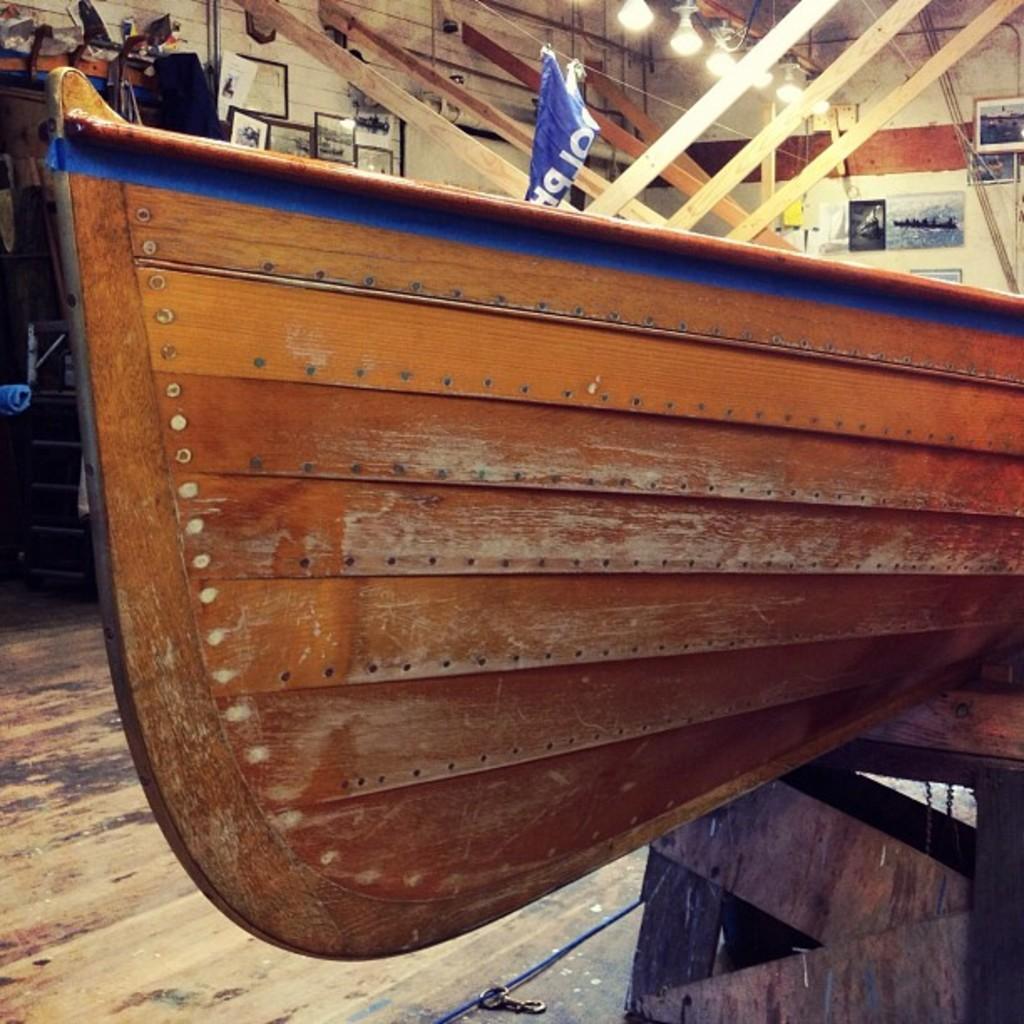Can you describe this image briefly? In this picture we can see a wooden object, banner, frames, lights and some objects and in the background we can see the wall. 